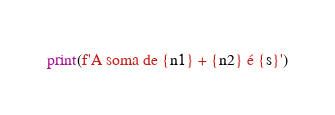Convert code to text. <code><loc_0><loc_0><loc_500><loc_500><_Python_>print(f'A soma de {n1} + {n2} é {s}')</code> 